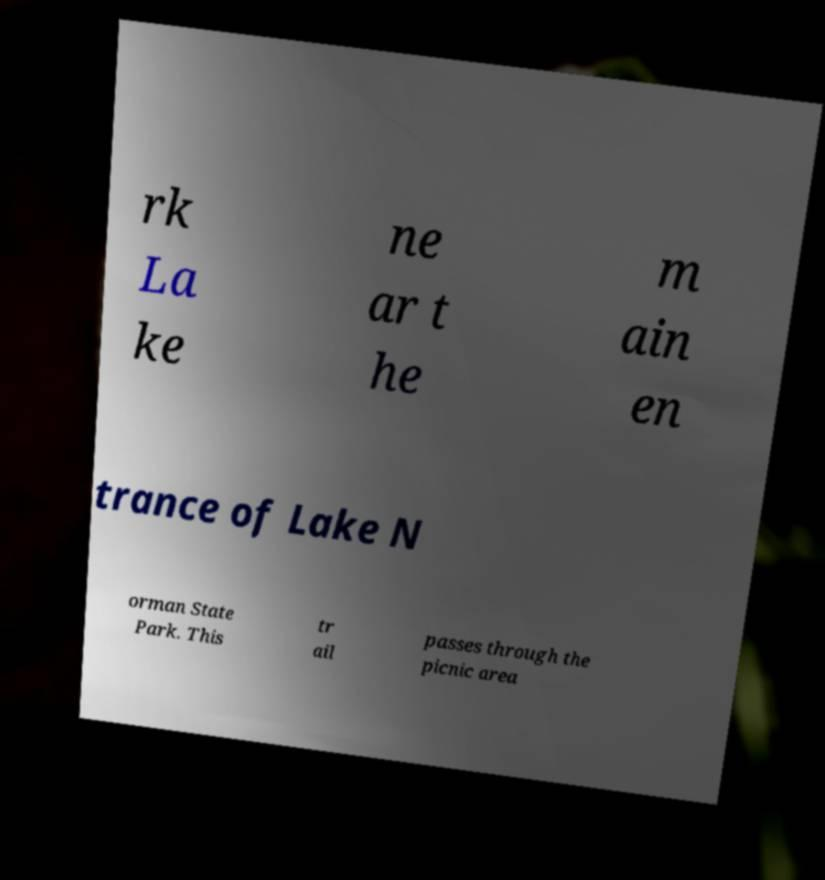What messages or text are displayed in this image? I need them in a readable, typed format. rk La ke ne ar t he m ain en trance of Lake N orman State Park. This tr ail passes through the picnic area 